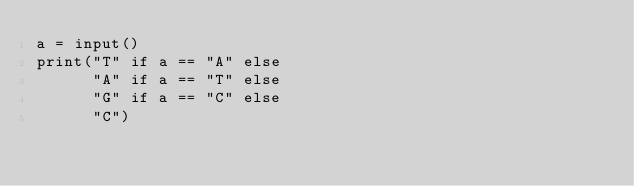<code> <loc_0><loc_0><loc_500><loc_500><_Python_>a = input()
print("T" if a == "A" else
      "A" if a == "T" else
      "G" if a == "C" else
      "C")
</code> 